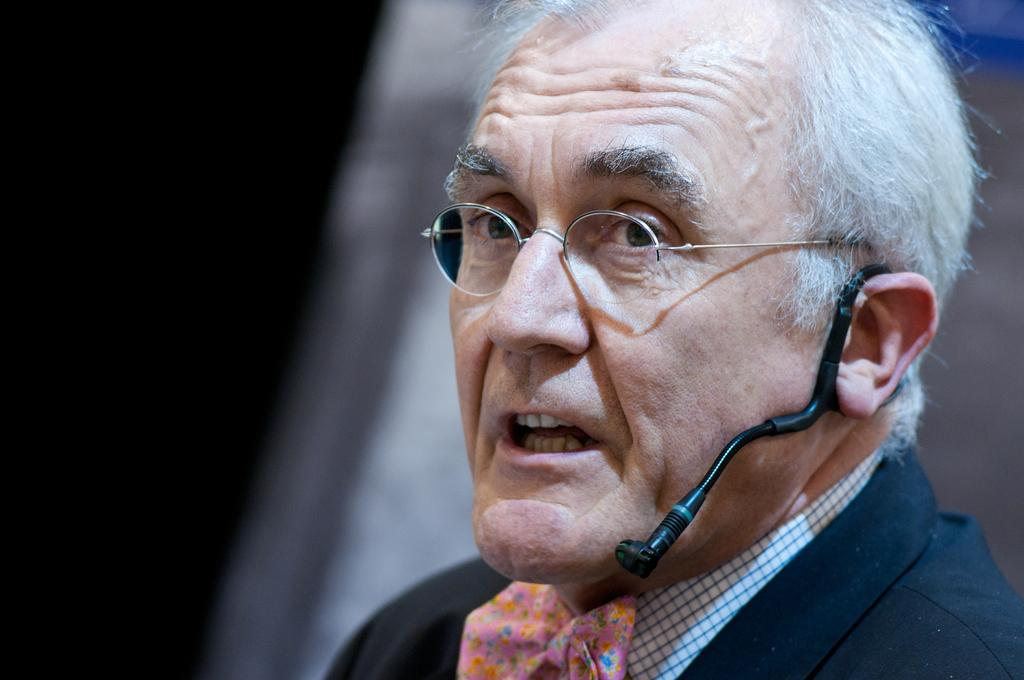What is the main subject of the image? The main subject of the image is a person. What is the person wearing in the image? The person is wearing a microphone and spectacles. Can you see the person's parent in the image? There is no reference to a parent in the image, so it's not possible to determine if the person's parent is present. Is there a bridge visible in the image? There is no bridge present in the image. 